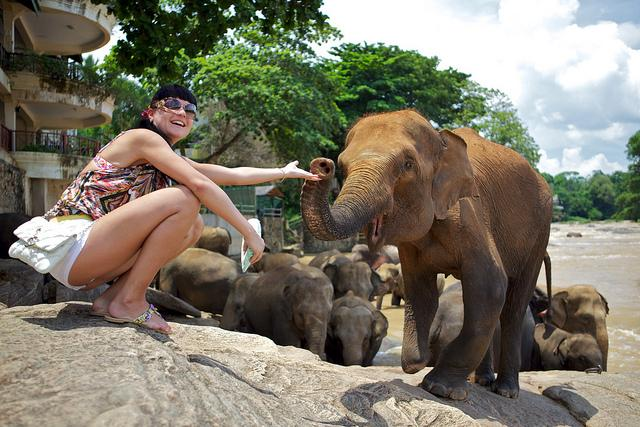What is climbing up the rocks to talk to the woman who is on the top?

Choices:
A) wolf
B) seal
C) elephant
D) penguin elephant 